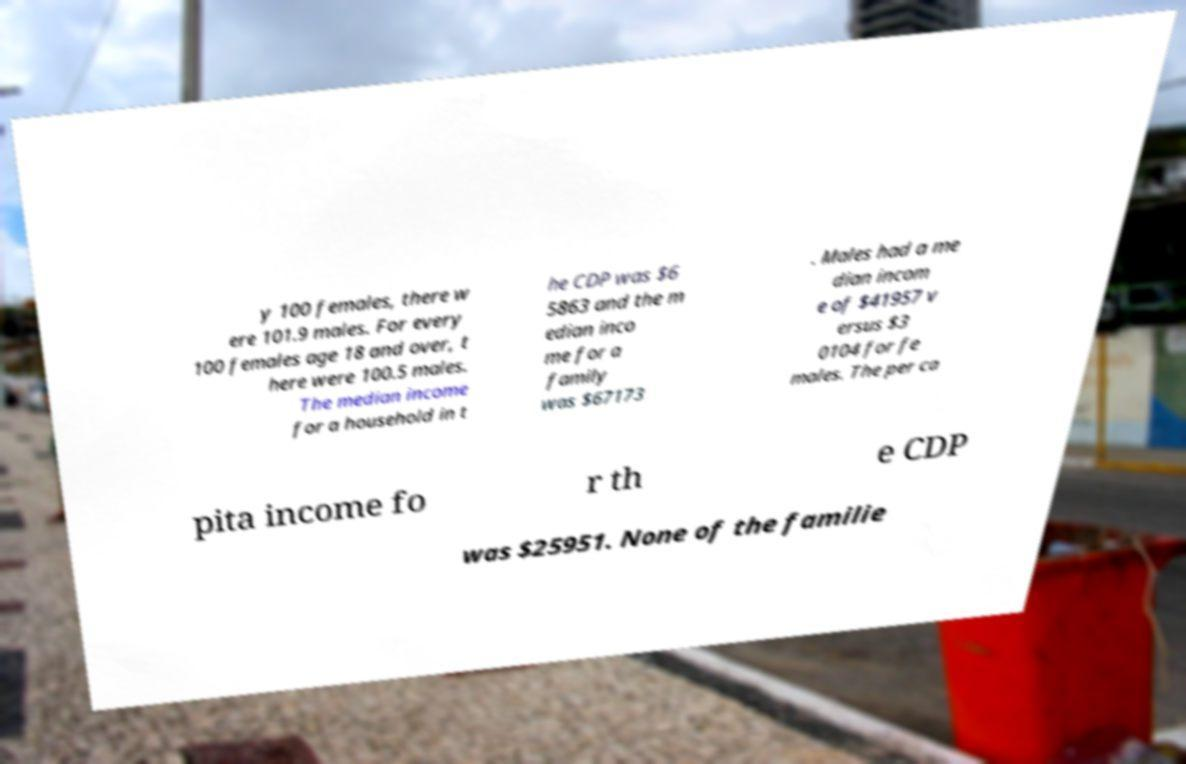What messages or text are displayed in this image? I need them in a readable, typed format. y 100 females, there w ere 101.9 males. For every 100 females age 18 and over, t here were 100.5 males. The median income for a household in t he CDP was $6 5863 and the m edian inco me for a family was $67173 . Males had a me dian incom e of $41957 v ersus $3 0104 for fe males. The per ca pita income fo r th e CDP was $25951. None of the familie 